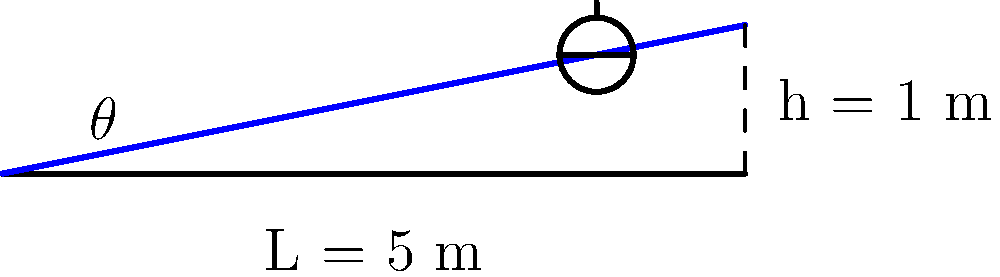As a retired judo athlete, you're consulting on the design of an accessible training facility. A ramp needs to be installed with a vertical rise of 1 meter over a horizontal distance of 5 meters. What is the angle $\theta$ of this ramp, and does it meet the ADA (Americans with Disabilities Act) standard maximum slope of 1:12 (4.76 degrees)? To solve this problem, we'll follow these steps:

1) First, we need to calculate the angle $\theta$ of the ramp. We can do this using basic trigonometry.

2) We have a right triangle where:
   - The opposite side (height) is 1 meter
   - The adjacent side (length) is 5 meters

3) To find the angle, we use the arctangent function:

   $$\theta = \arctan(\frac{\text{opposite}}{\text{adjacent}}) = \arctan(\frac{1}{5})$$

4) Calculate this value:
   $$\theta = \arctan(0.2) \approx 11.31 \text{ degrees}$$

5) Now, we need to compare this to the ADA standard:
   - ADA maximum slope: 1:12 or 4.76 degrees
   - Our ramp: 11.31 degrees

6) Since 11.31 degrees > 4.76 degrees, this ramp does not meet the ADA standard.

7) To meet the standard, the ramp would need to be longer. The minimum length for a 1 meter rise would be:
   $$L = \frac{1}{\tan(4.76°)} \approx 12 \text{ meters}$$
Answer: $\theta \approx 11.31°$; does not meet ADA standard 